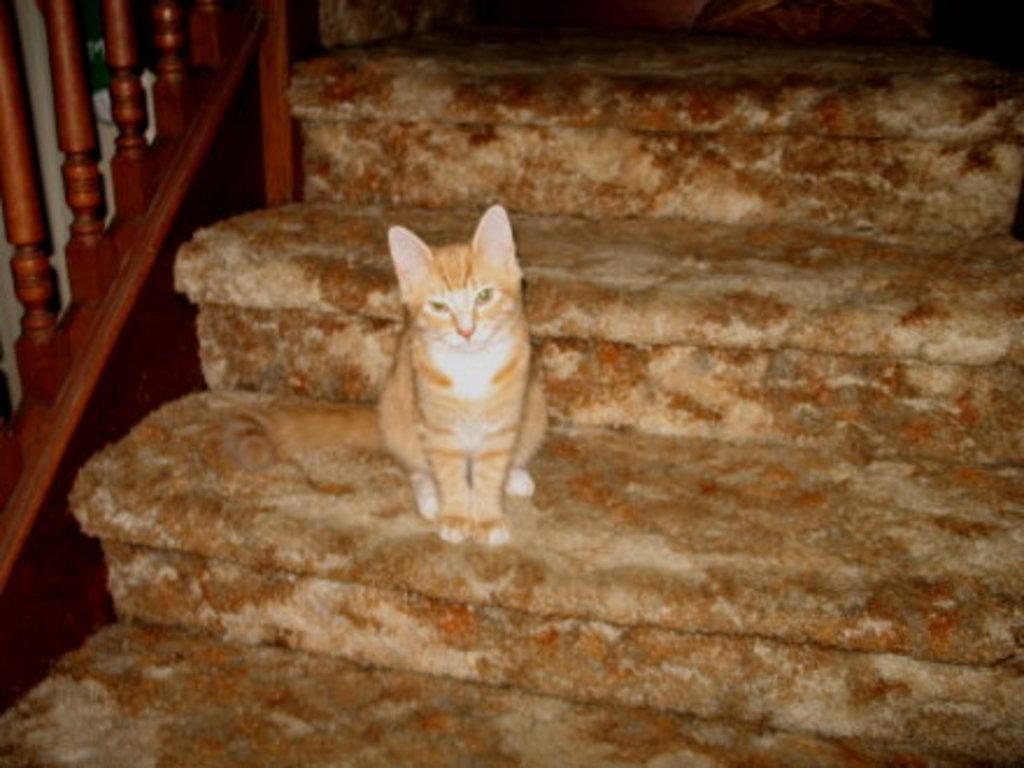What animal is present in the image? There is a cat in the image. Where is the cat located? The cat is on the stairs. What architectural feature can be seen in the image? There are balusters in the image. What does the cat's father say about the cat's desire to climb the stairs? There is no mention of the cat's father or desire in the image, so it is not possible to answer that question. 